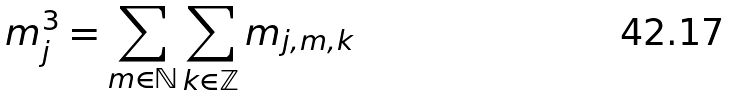Convert formula to latex. <formula><loc_0><loc_0><loc_500><loc_500>m _ { j } ^ { 3 } = \sum _ { m \in \mathbb { N } } \sum _ { k \in \mathbb { Z } } m _ { j , m , k }</formula> 